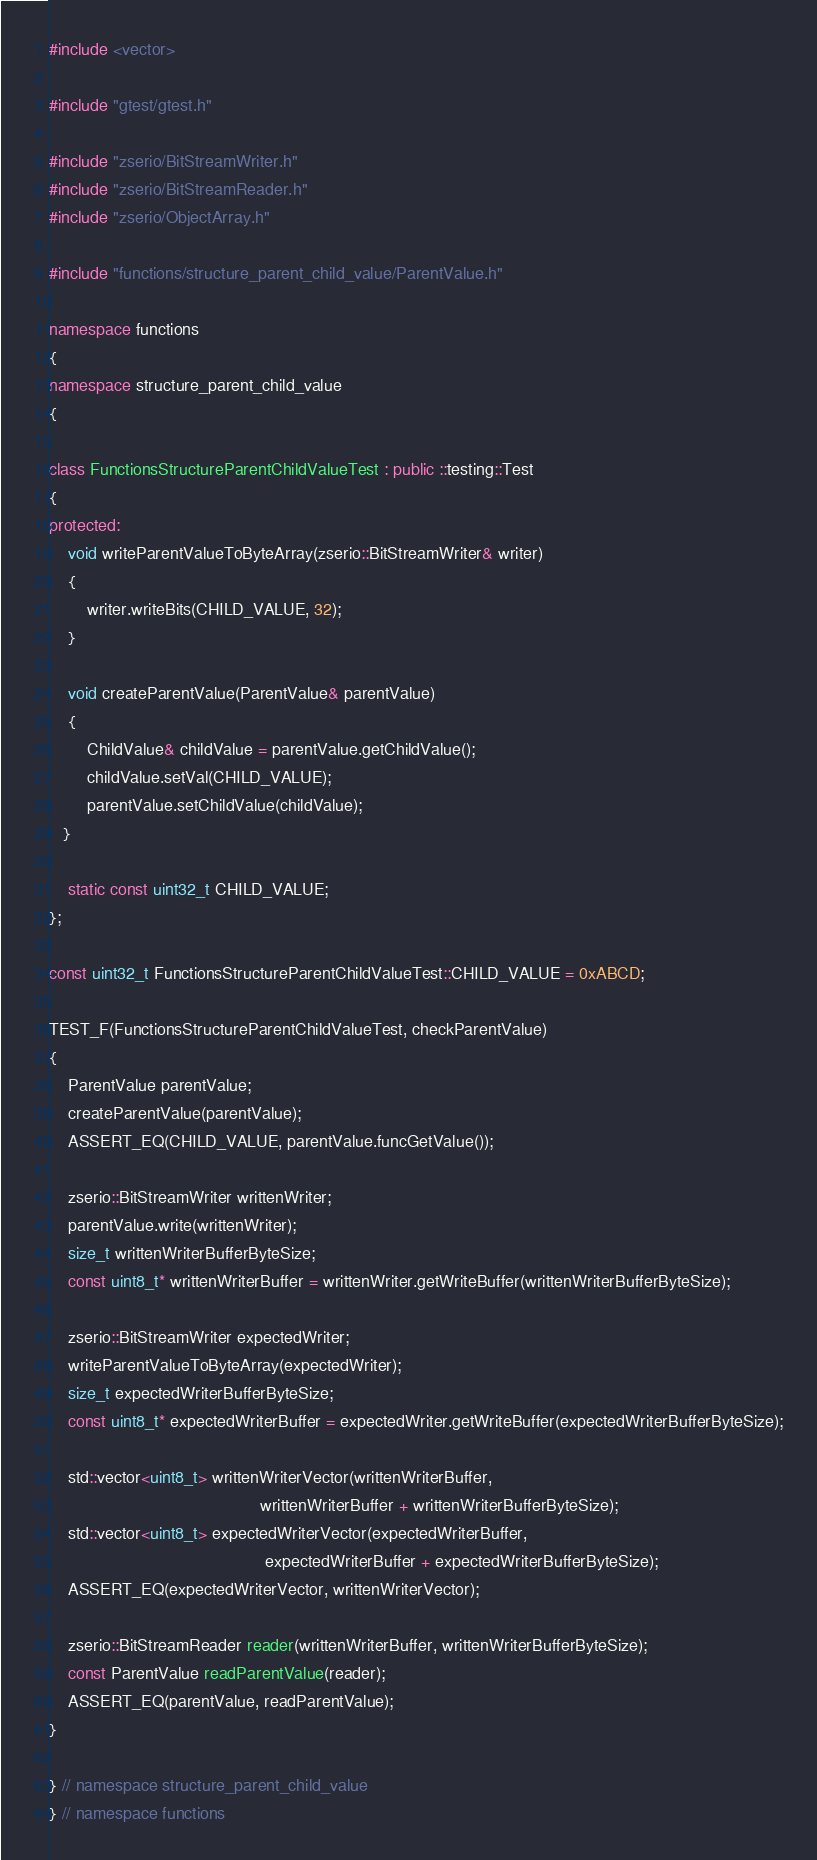Convert code to text. <code><loc_0><loc_0><loc_500><loc_500><_C++_>#include <vector>

#include "gtest/gtest.h"

#include "zserio/BitStreamWriter.h"
#include "zserio/BitStreamReader.h"
#include "zserio/ObjectArray.h"

#include "functions/structure_parent_child_value/ParentValue.h"

namespace functions
{
namespace structure_parent_child_value
{

class FunctionsStructureParentChildValueTest : public ::testing::Test
{
protected:
    void writeParentValueToByteArray(zserio::BitStreamWriter& writer)
    {
        writer.writeBits(CHILD_VALUE, 32);
    }

    void createParentValue(ParentValue& parentValue)
    {
        ChildValue& childValue = parentValue.getChildValue();
        childValue.setVal(CHILD_VALUE);
        parentValue.setChildValue(childValue);
   }

    static const uint32_t CHILD_VALUE;
};

const uint32_t FunctionsStructureParentChildValueTest::CHILD_VALUE = 0xABCD;

TEST_F(FunctionsStructureParentChildValueTest, checkParentValue)
{
    ParentValue parentValue;
    createParentValue(parentValue);
    ASSERT_EQ(CHILD_VALUE, parentValue.funcGetValue());

    zserio::BitStreamWriter writtenWriter;
    parentValue.write(writtenWriter);
    size_t writtenWriterBufferByteSize;
    const uint8_t* writtenWriterBuffer = writtenWriter.getWriteBuffer(writtenWriterBufferByteSize);

    zserio::BitStreamWriter expectedWriter;
    writeParentValueToByteArray(expectedWriter);
    size_t expectedWriterBufferByteSize;
    const uint8_t* expectedWriterBuffer = expectedWriter.getWriteBuffer(expectedWriterBufferByteSize);

    std::vector<uint8_t> writtenWriterVector(writtenWriterBuffer,
                                             writtenWriterBuffer + writtenWriterBufferByteSize);
    std::vector<uint8_t> expectedWriterVector(expectedWriterBuffer,
                                              expectedWriterBuffer + expectedWriterBufferByteSize);
    ASSERT_EQ(expectedWriterVector, writtenWriterVector);

    zserio::BitStreamReader reader(writtenWriterBuffer, writtenWriterBufferByteSize);
    const ParentValue readParentValue(reader);
    ASSERT_EQ(parentValue, readParentValue);
}

} // namespace structure_parent_child_value
} // namespace functions
</code> 